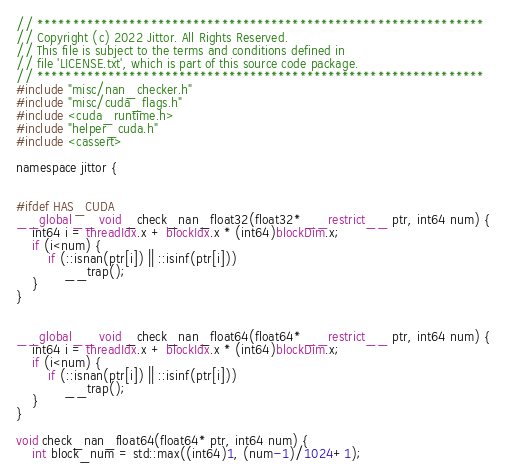<code> <loc_0><loc_0><loc_500><loc_500><_Cuda_>// ***************************************************************
// Copyright (c) 2022 Jittor. All Rights Reserved.
// This file is subject to the terms and conditions defined in
// file 'LICENSE.txt', which is part of this source code package.
// ***************************************************************
#include "misc/nan_checker.h"
#include "misc/cuda_flags.h"
#include <cuda_runtime.h>
#include "helper_cuda.h"
#include <cassert>

namespace jittor {


#ifdef HAS_CUDA
__global__ void _check_nan_float32(float32* __restrict__ ptr, int64 num) {
    int64 i = threadIdx.x + blockIdx.x * (int64)blockDim.x;
    if (i<num) {
        if (::isnan(ptr[i]) || ::isinf(ptr[i]))
            __trap();
    }
}


__global__ void _check_nan_float64(float64* __restrict__ ptr, int64 num) {
    int64 i = threadIdx.x + blockIdx.x * (int64)blockDim.x;
    if (i<num) {
        if (::isnan(ptr[i]) || ::isinf(ptr[i]))
            __trap();
    }
}

void check_nan_float64(float64* ptr, int64 num) {
    int block_num = std::max((int64)1, (num-1)/1024+1);</code> 